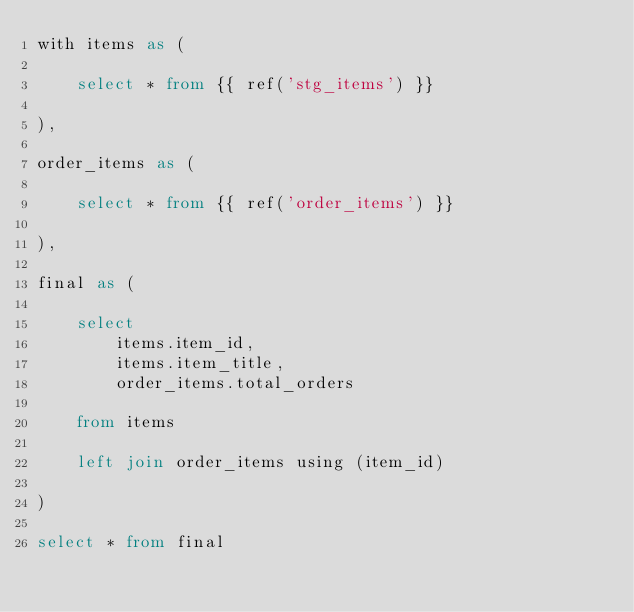Convert code to text. <code><loc_0><loc_0><loc_500><loc_500><_SQL_>with items as (

    select * from {{ ref('stg_items') }}

),

order_items as (

    select * from {{ ref('order_items') }}

),

final as (

    select
        items.item_id,
        items.item_title,
        order_items.total_orders

    from items

    left join order_items using (item_id)

)

select * from final
</code> 